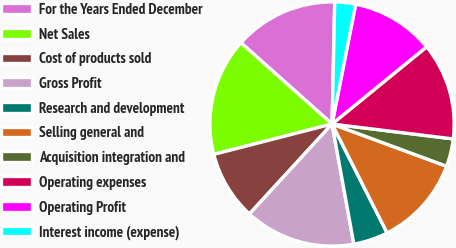Convert chart to OTSL. <chart><loc_0><loc_0><loc_500><loc_500><pie_chart><fcel>For the Years Ended December<fcel>Net Sales<fcel>Cost of products sold<fcel>Gross Profit<fcel>Research and development<fcel>Selling general and<fcel>Acquisition integration and<fcel>Operating expenses<fcel>Operating Profit<fcel>Interest income (expense)<nl><fcel>13.76%<fcel>15.59%<fcel>9.17%<fcel>14.68%<fcel>4.59%<fcel>11.93%<fcel>3.67%<fcel>12.84%<fcel>11.01%<fcel>2.75%<nl></chart> 